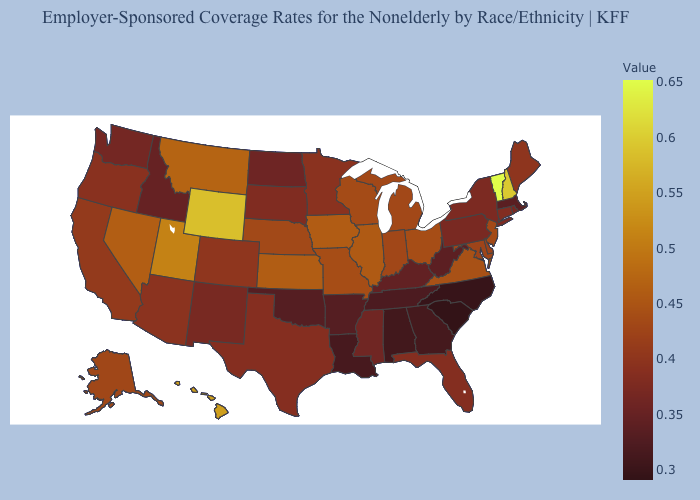Among the states that border Nebraska , which have the highest value?
Write a very short answer. Wyoming. Among the states that border Connecticut , which have the lowest value?
Concise answer only. Massachusetts. Which states have the highest value in the USA?
Write a very short answer. Vermont. Does Delaware have a lower value than Oklahoma?
Give a very brief answer. No. 